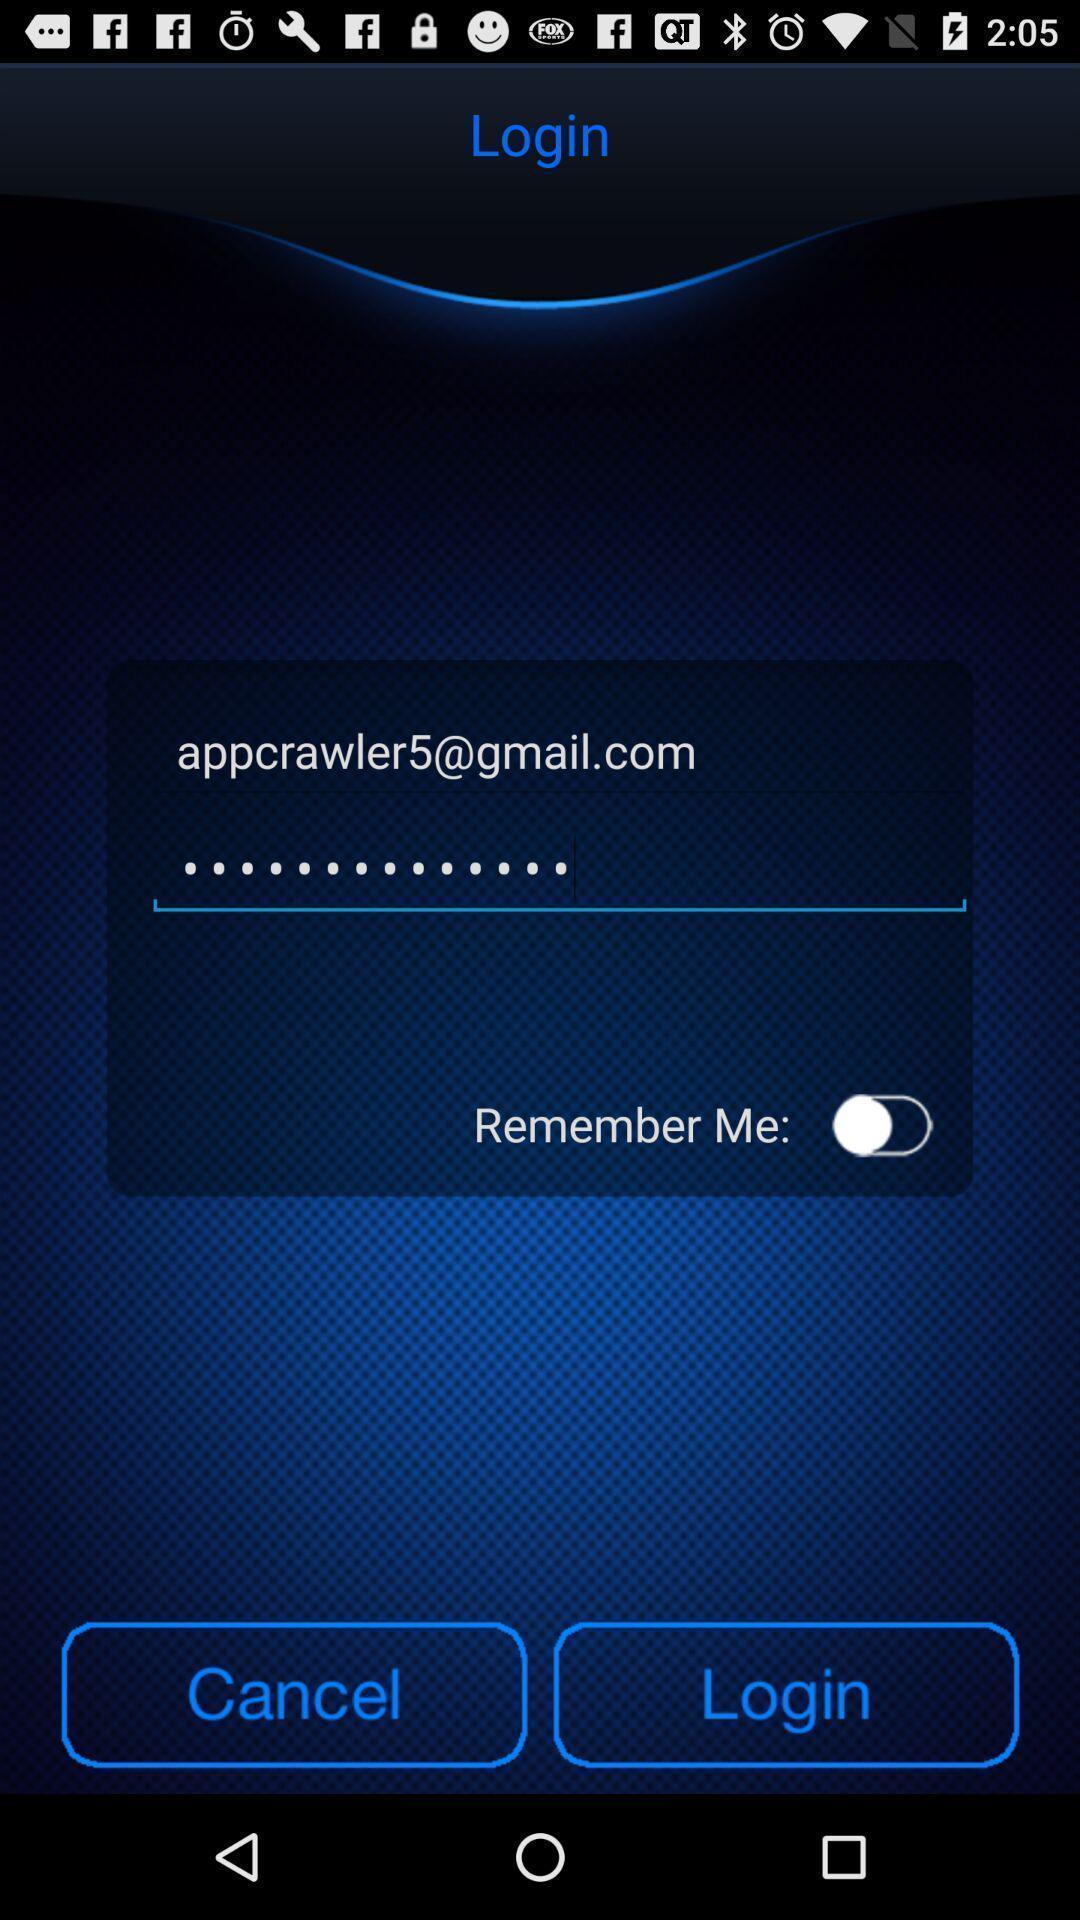Explain what's happening in this screen capture. Page displaying the login details. 